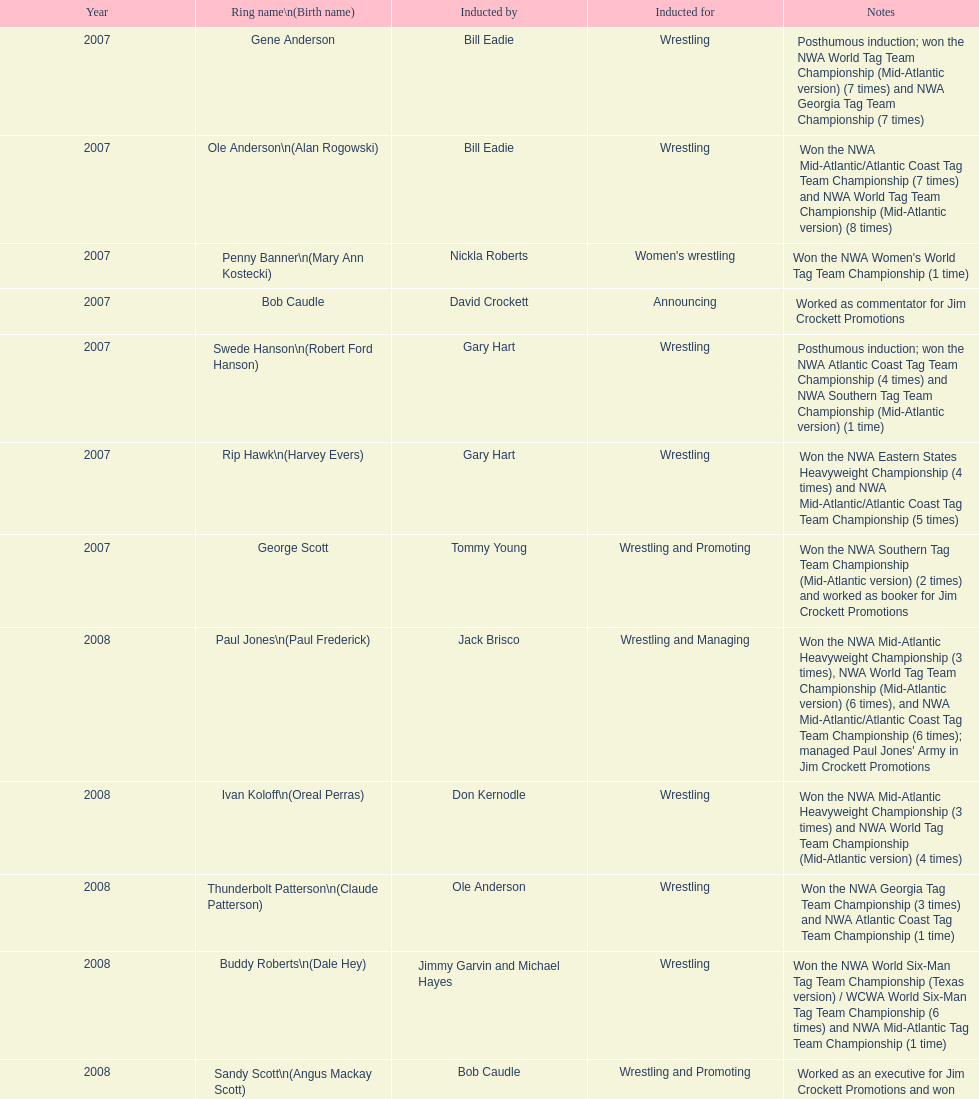Who has the actual name dale hey, grizzly smith, or buddy roberts? Buddy Roberts. 